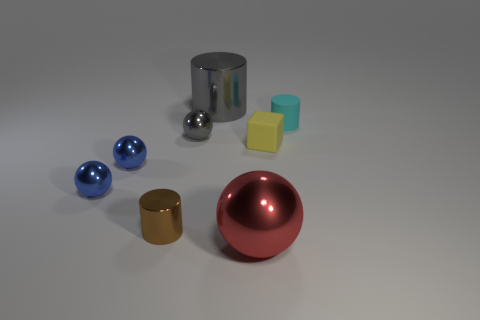What material is the small block that is to the right of the tiny gray shiny object that is to the right of the brown cylinder made of?
Provide a short and direct response. Rubber. How many other red metallic objects have the same shape as the big red object?
Offer a terse response. 0. What is the shape of the large gray shiny thing?
Make the answer very short. Cylinder. Are there fewer tiny red shiny cylinders than large red shiny spheres?
Ensure brevity in your answer.  Yes. Is there anything else that has the same size as the red metal ball?
Your answer should be very brief. Yes. There is a tiny cyan object that is the same shape as the big gray thing; what is it made of?
Ensure brevity in your answer.  Rubber. Are there more tiny gray spheres than rubber objects?
Keep it short and to the point. No. What number of other things are the same color as the big cylinder?
Offer a very short reply. 1. Do the big red thing and the cylinder in front of the small cyan matte cylinder have the same material?
Offer a very short reply. Yes. How many shiny cylinders are in front of the red shiny ball on the left side of the yellow matte object that is behind the tiny brown metal object?
Ensure brevity in your answer.  0. 